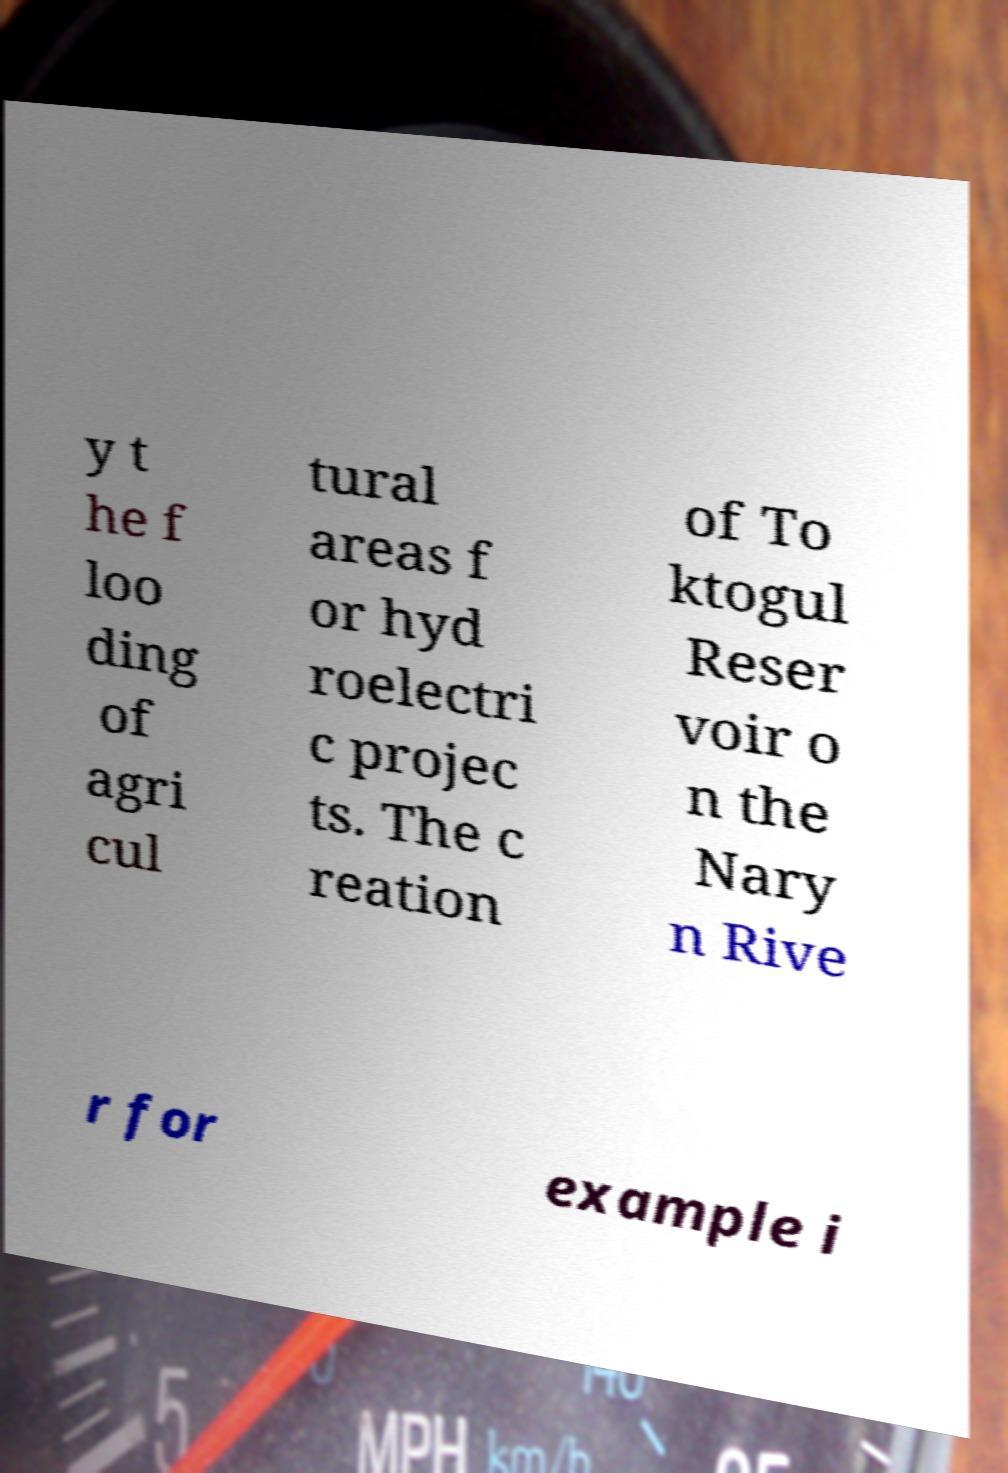Can you accurately transcribe the text from the provided image for me? y t he f loo ding of agri cul tural areas f or hyd roelectri c projec ts. The c reation of To ktogul Reser voir o n the Nary n Rive r for example i 